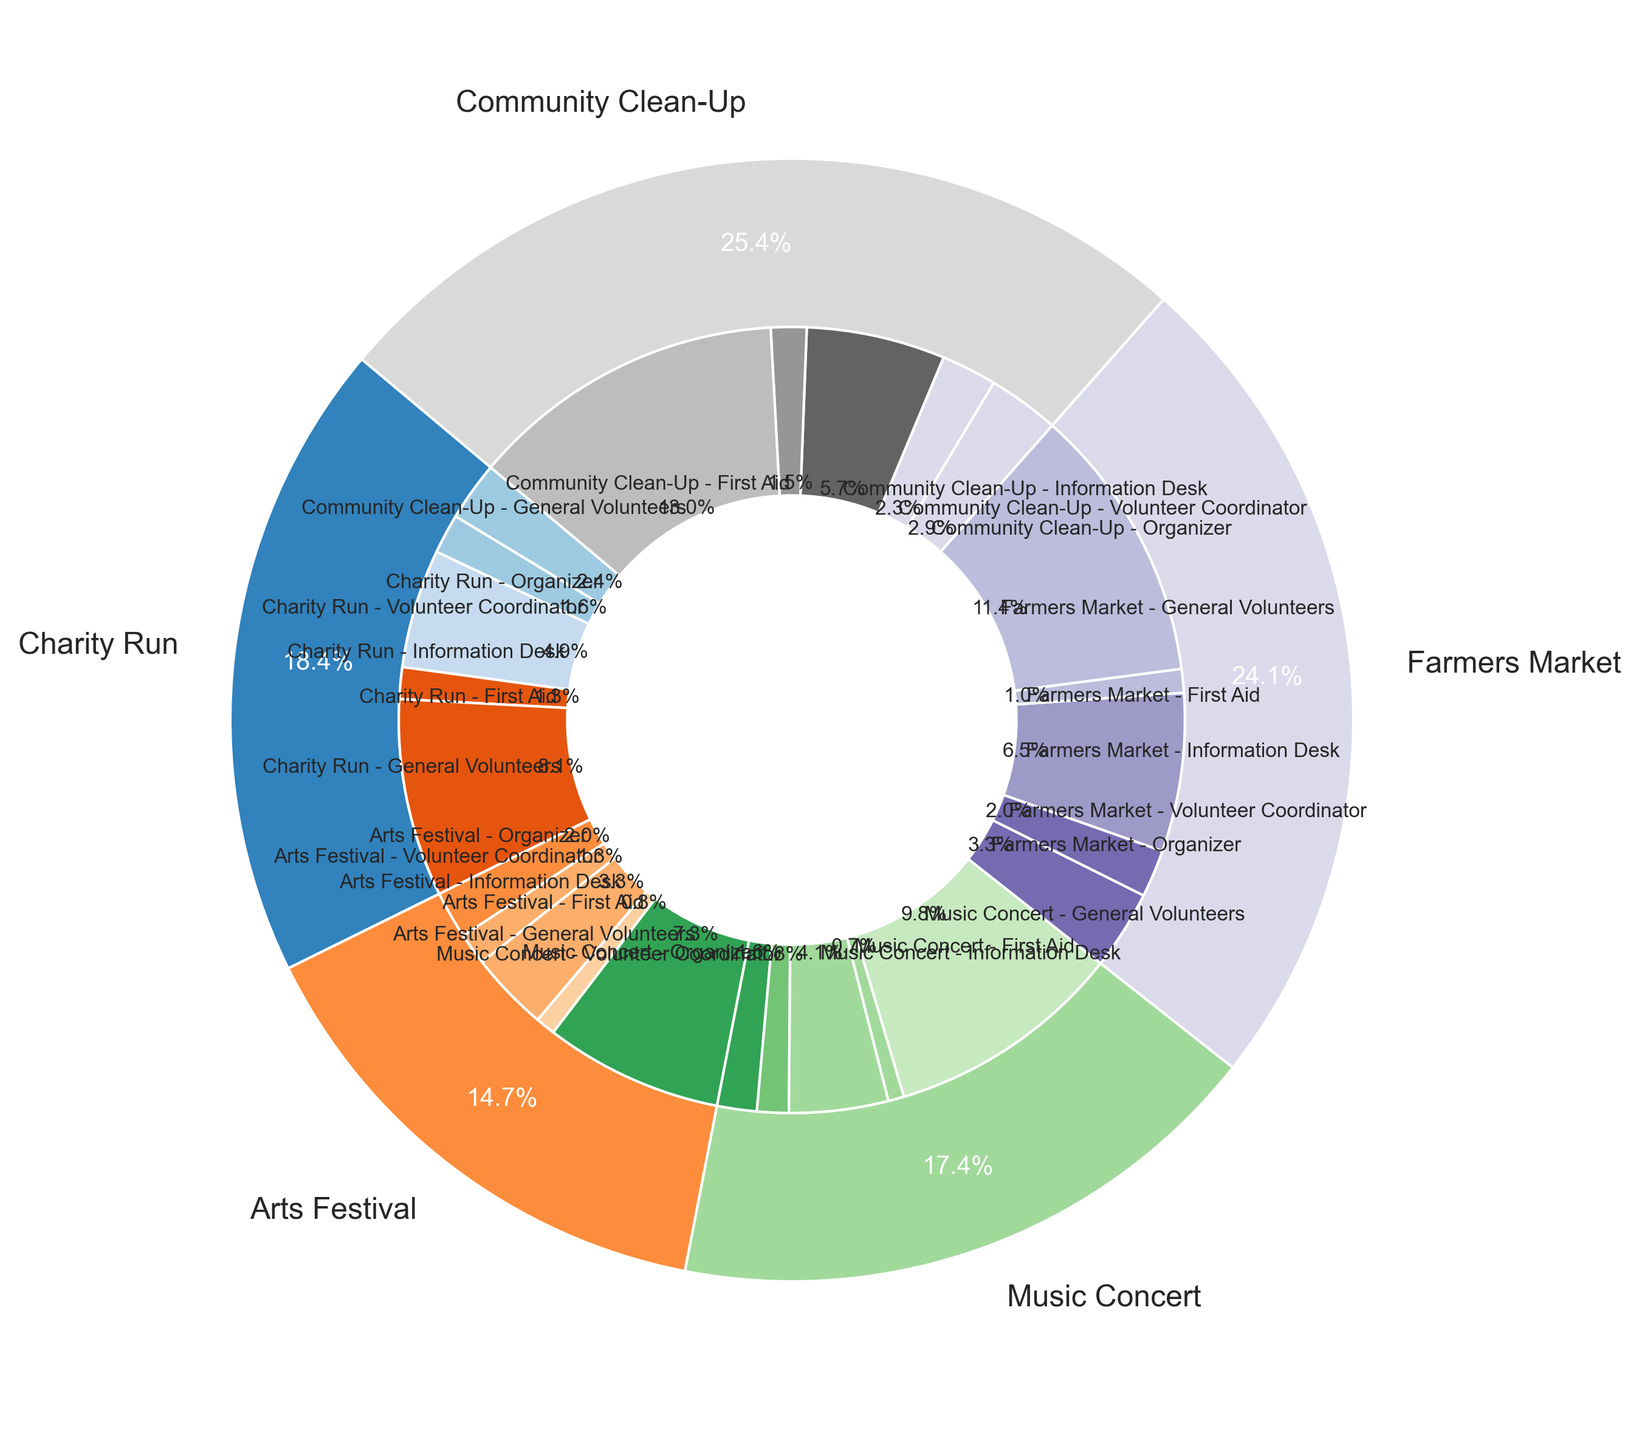How many volunteer roles had more than 40 participants in total? First, identify each role across all events and sum the counts for that role. General Volunteers roles exceed 40 participants in Charity Run (50), Arts Festival (45), Music Concert (60), Farmers Market (70), Community Clean-Up (80). Information Desk in Farmers Market has 40 participants. Other roles have counts below 40. Thus, there is 1 role (General Volunteers) where participants exceed 40 in all events combined.
Answer: 1 Which event had the highest number of total participants? Sum the participants for each event and compare. Charity Run: 113, Arts Festival: 90, Music Concert: 107, Farmers Market: 148, Community Clean-Up: 156. The Community Clean-Up has the highest total with 156 participants.
Answer: Community Clean-Up In which event did the Volunteer Coordinator role have the smallest percentage? Calculate the proportion of Volunteer Coordinators in each event: Charity Run (10/113 ≈ 8.8%), Arts Festival (8/90 ≈ 8.9%), Music Concert (8/107 ≈ 7.5%), Farmers Market (12/148 ≈ 8.1%), Community Clean-Up (14/156 ≈ 9%). The smallest percentage is in the Music Concert (7.5%).
Answer: Music Concert How many Organizers were there in total for all events? Sum the count of Organizers across all events: Charity Run (15), Arts Festival (12), Music Concert (10), Farmers Market (20), Community Clean-Up (18). 15 + 12 + 10 + 20 + 18 = 75.
Answer: 75 Which role had the least participants in the Farmers Market event? Review the Farmers Market counts per role: Organizer (20), Volunteer Coordinator (12), Information Desk (40), First Aid (6), General Volunteers (70). The First Aid role had the least participants with 6.
Answer: First Aid What's the total number of General Volunteers across all events? Sum the count of General Volunteers in each event: Charity Run (50), Arts Festival (45), Music Concert (60), Farmers Market (70), Community Clean-Up (80). 50 + 45 + 60 + 70 + 80 = 305.
Answer: 305 Compare the total number of participants in the Arts Festival to the Music Concert. Which has more? Sum the participants per event: Arts Festival (90), Music Concert (107). Compare the sums, Music Concert has more participants.
Answer: Music Concert What percentage of the Charity Run participants were at the Information Desk? Calculate the percentage for Charity Run Information Desk participants: (30/113) * 100 ≈ 26.5%. The percentage is approximately 26.5%.
Answer: 26.5% Which event had the highest proportion of First Aid participants? Calculate the proportion of First Aid participants for each event: Charity Run (8/113 ≈ 7.1%), Arts Festival (5/90 ≈ 5.6%), Music Concert (4/107 ≈ 3.7%), Farmers Market (6/148 ≈ 4.1%), Community Clean-Up (9/156 ≈ 5.8%). The highest proportion is in the Charity Run (7.1%).
Answer: Charity Run 